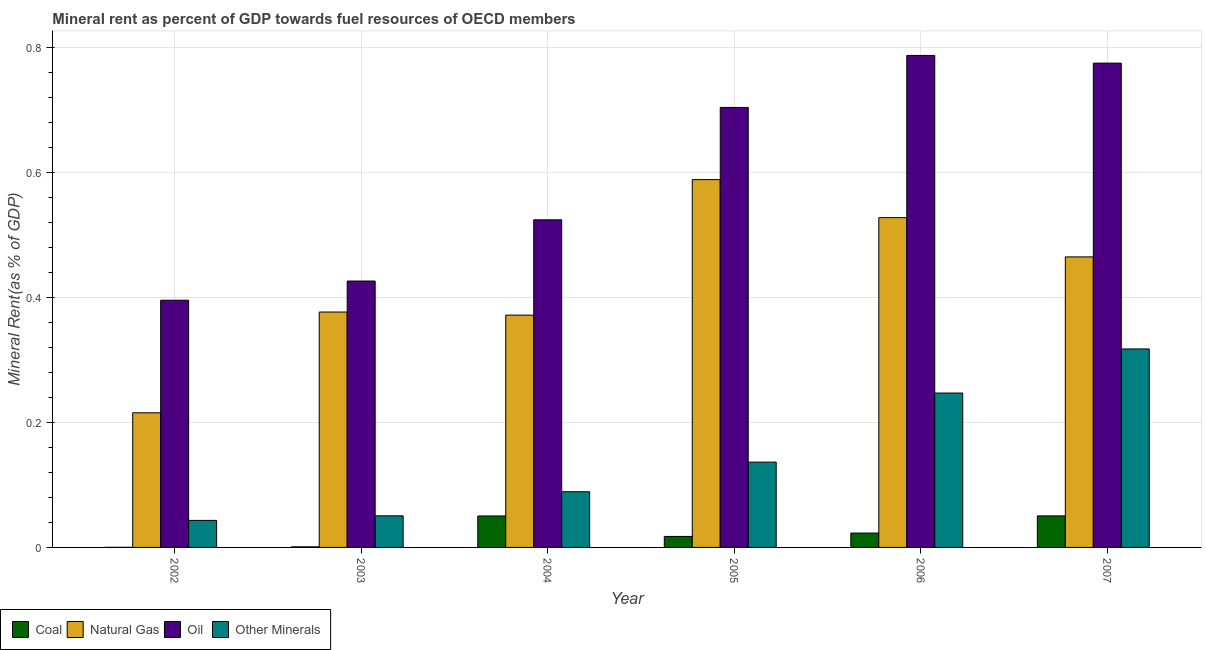How many different coloured bars are there?
Keep it short and to the point. 4. Are the number of bars per tick equal to the number of legend labels?
Offer a very short reply. Yes. Are the number of bars on each tick of the X-axis equal?
Offer a terse response. Yes. What is the label of the 1st group of bars from the left?
Your answer should be very brief. 2002. In how many cases, is the number of bars for a given year not equal to the number of legend labels?
Provide a succinct answer. 0. What is the natural gas rent in 2004?
Your response must be concise. 0.37. Across all years, what is the maximum natural gas rent?
Give a very brief answer. 0.59. Across all years, what is the minimum natural gas rent?
Your answer should be very brief. 0.22. What is the total coal rent in the graph?
Ensure brevity in your answer.  0.14. What is the difference between the coal rent in 2005 and that in 2006?
Provide a short and direct response. -0.01. What is the difference between the  rent of other minerals in 2004 and the coal rent in 2006?
Offer a very short reply. -0.16. What is the average  rent of other minerals per year?
Offer a very short reply. 0.15. In how many years, is the  rent of other minerals greater than 0.68 %?
Keep it short and to the point. 0. What is the ratio of the natural gas rent in 2004 to that in 2005?
Provide a succinct answer. 0.63. Is the difference between the coal rent in 2004 and 2006 greater than the difference between the oil rent in 2004 and 2006?
Offer a very short reply. No. What is the difference between the highest and the second highest natural gas rent?
Make the answer very short. 0.06. What is the difference between the highest and the lowest coal rent?
Ensure brevity in your answer.  0.05. Is it the case that in every year, the sum of the natural gas rent and coal rent is greater than the sum of oil rent and  rent of other minerals?
Your response must be concise. Yes. What does the 2nd bar from the left in 2006 represents?
Keep it short and to the point. Natural Gas. What does the 1st bar from the right in 2002 represents?
Your answer should be very brief. Other Minerals. Are all the bars in the graph horizontal?
Provide a succinct answer. No. How many years are there in the graph?
Keep it short and to the point. 6. What is the difference between two consecutive major ticks on the Y-axis?
Your answer should be very brief. 0.2. Are the values on the major ticks of Y-axis written in scientific E-notation?
Make the answer very short. No. Does the graph contain grids?
Your answer should be very brief. Yes. Where does the legend appear in the graph?
Keep it short and to the point. Bottom left. What is the title of the graph?
Your answer should be very brief. Mineral rent as percent of GDP towards fuel resources of OECD members. What is the label or title of the Y-axis?
Offer a very short reply. Mineral Rent(as % of GDP). What is the Mineral Rent(as % of GDP) in Coal in 2002?
Keep it short and to the point. 0. What is the Mineral Rent(as % of GDP) of Natural Gas in 2002?
Give a very brief answer. 0.22. What is the Mineral Rent(as % of GDP) in Oil in 2002?
Your answer should be compact. 0.4. What is the Mineral Rent(as % of GDP) in Other Minerals in 2002?
Your answer should be compact. 0.04. What is the Mineral Rent(as % of GDP) in Coal in 2003?
Offer a very short reply. 0. What is the Mineral Rent(as % of GDP) in Natural Gas in 2003?
Ensure brevity in your answer.  0.38. What is the Mineral Rent(as % of GDP) of Oil in 2003?
Your response must be concise. 0.43. What is the Mineral Rent(as % of GDP) of Other Minerals in 2003?
Offer a terse response. 0.05. What is the Mineral Rent(as % of GDP) in Coal in 2004?
Your answer should be very brief. 0.05. What is the Mineral Rent(as % of GDP) of Natural Gas in 2004?
Offer a terse response. 0.37. What is the Mineral Rent(as % of GDP) in Oil in 2004?
Provide a succinct answer. 0.52. What is the Mineral Rent(as % of GDP) in Other Minerals in 2004?
Your answer should be very brief. 0.09. What is the Mineral Rent(as % of GDP) of Coal in 2005?
Your answer should be compact. 0.02. What is the Mineral Rent(as % of GDP) in Natural Gas in 2005?
Offer a terse response. 0.59. What is the Mineral Rent(as % of GDP) in Oil in 2005?
Your answer should be compact. 0.7. What is the Mineral Rent(as % of GDP) of Other Minerals in 2005?
Your response must be concise. 0.14. What is the Mineral Rent(as % of GDP) in Coal in 2006?
Provide a short and direct response. 0.02. What is the Mineral Rent(as % of GDP) in Natural Gas in 2006?
Keep it short and to the point. 0.53. What is the Mineral Rent(as % of GDP) of Oil in 2006?
Provide a succinct answer. 0.79. What is the Mineral Rent(as % of GDP) of Other Minerals in 2006?
Your answer should be compact. 0.25. What is the Mineral Rent(as % of GDP) of Coal in 2007?
Keep it short and to the point. 0.05. What is the Mineral Rent(as % of GDP) of Natural Gas in 2007?
Offer a terse response. 0.46. What is the Mineral Rent(as % of GDP) of Oil in 2007?
Your answer should be very brief. 0.77. What is the Mineral Rent(as % of GDP) in Other Minerals in 2007?
Offer a terse response. 0.32. Across all years, what is the maximum Mineral Rent(as % of GDP) in Coal?
Ensure brevity in your answer.  0.05. Across all years, what is the maximum Mineral Rent(as % of GDP) in Natural Gas?
Keep it short and to the point. 0.59. Across all years, what is the maximum Mineral Rent(as % of GDP) in Oil?
Provide a succinct answer. 0.79. Across all years, what is the maximum Mineral Rent(as % of GDP) of Other Minerals?
Your answer should be very brief. 0.32. Across all years, what is the minimum Mineral Rent(as % of GDP) of Coal?
Ensure brevity in your answer.  0. Across all years, what is the minimum Mineral Rent(as % of GDP) of Natural Gas?
Give a very brief answer. 0.22. Across all years, what is the minimum Mineral Rent(as % of GDP) in Oil?
Your answer should be compact. 0.4. Across all years, what is the minimum Mineral Rent(as % of GDP) of Other Minerals?
Provide a succinct answer. 0.04. What is the total Mineral Rent(as % of GDP) of Coal in the graph?
Your answer should be compact. 0.14. What is the total Mineral Rent(as % of GDP) in Natural Gas in the graph?
Provide a short and direct response. 2.54. What is the total Mineral Rent(as % of GDP) of Oil in the graph?
Make the answer very short. 3.61. What is the total Mineral Rent(as % of GDP) in Other Minerals in the graph?
Provide a short and direct response. 0.88. What is the difference between the Mineral Rent(as % of GDP) of Coal in 2002 and that in 2003?
Give a very brief answer. -0. What is the difference between the Mineral Rent(as % of GDP) of Natural Gas in 2002 and that in 2003?
Give a very brief answer. -0.16. What is the difference between the Mineral Rent(as % of GDP) of Oil in 2002 and that in 2003?
Provide a short and direct response. -0.03. What is the difference between the Mineral Rent(as % of GDP) of Other Minerals in 2002 and that in 2003?
Your answer should be compact. -0.01. What is the difference between the Mineral Rent(as % of GDP) of Coal in 2002 and that in 2004?
Your answer should be very brief. -0.05. What is the difference between the Mineral Rent(as % of GDP) of Natural Gas in 2002 and that in 2004?
Ensure brevity in your answer.  -0.16. What is the difference between the Mineral Rent(as % of GDP) of Oil in 2002 and that in 2004?
Ensure brevity in your answer.  -0.13. What is the difference between the Mineral Rent(as % of GDP) of Other Minerals in 2002 and that in 2004?
Keep it short and to the point. -0.05. What is the difference between the Mineral Rent(as % of GDP) in Coal in 2002 and that in 2005?
Make the answer very short. -0.02. What is the difference between the Mineral Rent(as % of GDP) of Natural Gas in 2002 and that in 2005?
Provide a short and direct response. -0.37. What is the difference between the Mineral Rent(as % of GDP) of Oil in 2002 and that in 2005?
Your answer should be compact. -0.31. What is the difference between the Mineral Rent(as % of GDP) of Other Minerals in 2002 and that in 2005?
Your response must be concise. -0.09. What is the difference between the Mineral Rent(as % of GDP) of Coal in 2002 and that in 2006?
Your answer should be compact. -0.02. What is the difference between the Mineral Rent(as % of GDP) of Natural Gas in 2002 and that in 2006?
Give a very brief answer. -0.31. What is the difference between the Mineral Rent(as % of GDP) in Oil in 2002 and that in 2006?
Your answer should be compact. -0.39. What is the difference between the Mineral Rent(as % of GDP) in Other Minerals in 2002 and that in 2006?
Offer a very short reply. -0.2. What is the difference between the Mineral Rent(as % of GDP) of Coal in 2002 and that in 2007?
Offer a very short reply. -0.05. What is the difference between the Mineral Rent(as % of GDP) in Natural Gas in 2002 and that in 2007?
Keep it short and to the point. -0.25. What is the difference between the Mineral Rent(as % of GDP) in Oil in 2002 and that in 2007?
Your answer should be very brief. -0.38. What is the difference between the Mineral Rent(as % of GDP) of Other Minerals in 2002 and that in 2007?
Give a very brief answer. -0.27. What is the difference between the Mineral Rent(as % of GDP) in Coal in 2003 and that in 2004?
Ensure brevity in your answer.  -0.05. What is the difference between the Mineral Rent(as % of GDP) in Natural Gas in 2003 and that in 2004?
Provide a short and direct response. 0.01. What is the difference between the Mineral Rent(as % of GDP) in Oil in 2003 and that in 2004?
Offer a terse response. -0.1. What is the difference between the Mineral Rent(as % of GDP) of Other Minerals in 2003 and that in 2004?
Provide a succinct answer. -0.04. What is the difference between the Mineral Rent(as % of GDP) of Coal in 2003 and that in 2005?
Your answer should be very brief. -0.02. What is the difference between the Mineral Rent(as % of GDP) of Natural Gas in 2003 and that in 2005?
Your answer should be very brief. -0.21. What is the difference between the Mineral Rent(as % of GDP) of Oil in 2003 and that in 2005?
Your answer should be very brief. -0.28. What is the difference between the Mineral Rent(as % of GDP) of Other Minerals in 2003 and that in 2005?
Provide a short and direct response. -0.09. What is the difference between the Mineral Rent(as % of GDP) of Coal in 2003 and that in 2006?
Offer a terse response. -0.02. What is the difference between the Mineral Rent(as % of GDP) in Natural Gas in 2003 and that in 2006?
Make the answer very short. -0.15. What is the difference between the Mineral Rent(as % of GDP) of Oil in 2003 and that in 2006?
Your answer should be very brief. -0.36. What is the difference between the Mineral Rent(as % of GDP) of Other Minerals in 2003 and that in 2006?
Provide a short and direct response. -0.2. What is the difference between the Mineral Rent(as % of GDP) of Coal in 2003 and that in 2007?
Your response must be concise. -0.05. What is the difference between the Mineral Rent(as % of GDP) of Natural Gas in 2003 and that in 2007?
Your answer should be compact. -0.09. What is the difference between the Mineral Rent(as % of GDP) of Oil in 2003 and that in 2007?
Provide a succinct answer. -0.35. What is the difference between the Mineral Rent(as % of GDP) of Other Minerals in 2003 and that in 2007?
Offer a very short reply. -0.27. What is the difference between the Mineral Rent(as % of GDP) in Coal in 2004 and that in 2005?
Give a very brief answer. 0.03. What is the difference between the Mineral Rent(as % of GDP) in Natural Gas in 2004 and that in 2005?
Make the answer very short. -0.22. What is the difference between the Mineral Rent(as % of GDP) of Oil in 2004 and that in 2005?
Offer a very short reply. -0.18. What is the difference between the Mineral Rent(as % of GDP) of Other Minerals in 2004 and that in 2005?
Offer a terse response. -0.05. What is the difference between the Mineral Rent(as % of GDP) of Coal in 2004 and that in 2006?
Provide a succinct answer. 0.03. What is the difference between the Mineral Rent(as % of GDP) of Natural Gas in 2004 and that in 2006?
Provide a succinct answer. -0.16. What is the difference between the Mineral Rent(as % of GDP) of Oil in 2004 and that in 2006?
Offer a very short reply. -0.26. What is the difference between the Mineral Rent(as % of GDP) in Other Minerals in 2004 and that in 2006?
Offer a terse response. -0.16. What is the difference between the Mineral Rent(as % of GDP) of Coal in 2004 and that in 2007?
Your answer should be compact. -0. What is the difference between the Mineral Rent(as % of GDP) of Natural Gas in 2004 and that in 2007?
Your answer should be compact. -0.09. What is the difference between the Mineral Rent(as % of GDP) in Oil in 2004 and that in 2007?
Keep it short and to the point. -0.25. What is the difference between the Mineral Rent(as % of GDP) in Other Minerals in 2004 and that in 2007?
Ensure brevity in your answer.  -0.23. What is the difference between the Mineral Rent(as % of GDP) of Coal in 2005 and that in 2006?
Make the answer very short. -0.01. What is the difference between the Mineral Rent(as % of GDP) in Natural Gas in 2005 and that in 2006?
Make the answer very short. 0.06. What is the difference between the Mineral Rent(as % of GDP) of Oil in 2005 and that in 2006?
Your answer should be compact. -0.08. What is the difference between the Mineral Rent(as % of GDP) of Other Minerals in 2005 and that in 2006?
Give a very brief answer. -0.11. What is the difference between the Mineral Rent(as % of GDP) of Coal in 2005 and that in 2007?
Offer a very short reply. -0.03. What is the difference between the Mineral Rent(as % of GDP) in Natural Gas in 2005 and that in 2007?
Offer a very short reply. 0.12. What is the difference between the Mineral Rent(as % of GDP) in Oil in 2005 and that in 2007?
Provide a short and direct response. -0.07. What is the difference between the Mineral Rent(as % of GDP) in Other Minerals in 2005 and that in 2007?
Your response must be concise. -0.18. What is the difference between the Mineral Rent(as % of GDP) in Coal in 2006 and that in 2007?
Provide a short and direct response. -0.03. What is the difference between the Mineral Rent(as % of GDP) in Natural Gas in 2006 and that in 2007?
Provide a short and direct response. 0.06. What is the difference between the Mineral Rent(as % of GDP) in Oil in 2006 and that in 2007?
Your answer should be compact. 0.01. What is the difference between the Mineral Rent(as % of GDP) of Other Minerals in 2006 and that in 2007?
Your answer should be very brief. -0.07. What is the difference between the Mineral Rent(as % of GDP) of Coal in 2002 and the Mineral Rent(as % of GDP) of Natural Gas in 2003?
Ensure brevity in your answer.  -0.38. What is the difference between the Mineral Rent(as % of GDP) of Coal in 2002 and the Mineral Rent(as % of GDP) of Oil in 2003?
Your answer should be compact. -0.43. What is the difference between the Mineral Rent(as % of GDP) in Coal in 2002 and the Mineral Rent(as % of GDP) in Other Minerals in 2003?
Provide a succinct answer. -0.05. What is the difference between the Mineral Rent(as % of GDP) of Natural Gas in 2002 and the Mineral Rent(as % of GDP) of Oil in 2003?
Your answer should be compact. -0.21. What is the difference between the Mineral Rent(as % of GDP) of Natural Gas in 2002 and the Mineral Rent(as % of GDP) of Other Minerals in 2003?
Your answer should be very brief. 0.16. What is the difference between the Mineral Rent(as % of GDP) in Oil in 2002 and the Mineral Rent(as % of GDP) in Other Minerals in 2003?
Provide a succinct answer. 0.34. What is the difference between the Mineral Rent(as % of GDP) of Coal in 2002 and the Mineral Rent(as % of GDP) of Natural Gas in 2004?
Provide a succinct answer. -0.37. What is the difference between the Mineral Rent(as % of GDP) of Coal in 2002 and the Mineral Rent(as % of GDP) of Oil in 2004?
Give a very brief answer. -0.52. What is the difference between the Mineral Rent(as % of GDP) in Coal in 2002 and the Mineral Rent(as % of GDP) in Other Minerals in 2004?
Provide a succinct answer. -0.09. What is the difference between the Mineral Rent(as % of GDP) in Natural Gas in 2002 and the Mineral Rent(as % of GDP) in Oil in 2004?
Your response must be concise. -0.31. What is the difference between the Mineral Rent(as % of GDP) of Natural Gas in 2002 and the Mineral Rent(as % of GDP) of Other Minerals in 2004?
Keep it short and to the point. 0.13. What is the difference between the Mineral Rent(as % of GDP) of Oil in 2002 and the Mineral Rent(as % of GDP) of Other Minerals in 2004?
Provide a short and direct response. 0.31. What is the difference between the Mineral Rent(as % of GDP) in Coal in 2002 and the Mineral Rent(as % of GDP) in Natural Gas in 2005?
Provide a succinct answer. -0.59. What is the difference between the Mineral Rent(as % of GDP) in Coal in 2002 and the Mineral Rent(as % of GDP) in Oil in 2005?
Give a very brief answer. -0.7. What is the difference between the Mineral Rent(as % of GDP) of Coal in 2002 and the Mineral Rent(as % of GDP) of Other Minerals in 2005?
Your answer should be compact. -0.14. What is the difference between the Mineral Rent(as % of GDP) of Natural Gas in 2002 and the Mineral Rent(as % of GDP) of Oil in 2005?
Give a very brief answer. -0.49. What is the difference between the Mineral Rent(as % of GDP) in Natural Gas in 2002 and the Mineral Rent(as % of GDP) in Other Minerals in 2005?
Ensure brevity in your answer.  0.08. What is the difference between the Mineral Rent(as % of GDP) of Oil in 2002 and the Mineral Rent(as % of GDP) of Other Minerals in 2005?
Provide a succinct answer. 0.26. What is the difference between the Mineral Rent(as % of GDP) of Coal in 2002 and the Mineral Rent(as % of GDP) of Natural Gas in 2006?
Provide a succinct answer. -0.53. What is the difference between the Mineral Rent(as % of GDP) in Coal in 2002 and the Mineral Rent(as % of GDP) in Oil in 2006?
Give a very brief answer. -0.79. What is the difference between the Mineral Rent(as % of GDP) in Coal in 2002 and the Mineral Rent(as % of GDP) in Other Minerals in 2006?
Provide a short and direct response. -0.25. What is the difference between the Mineral Rent(as % of GDP) of Natural Gas in 2002 and the Mineral Rent(as % of GDP) of Oil in 2006?
Ensure brevity in your answer.  -0.57. What is the difference between the Mineral Rent(as % of GDP) in Natural Gas in 2002 and the Mineral Rent(as % of GDP) in Other Minerals in 2006?
Give a very brief answer. -0.03. What is the difference between the Mineral Rent(as % of GDP) of Oil in 2002 and the Mineral Rent(as % of GDP) of Other Minerals in 2006?
Provide a short and direct response. 0.15. What is the difference between the Mineral Rent(as % of GDP) in Coal in 2002 and the Mineral Rent(as % of GDP) in Natural Gas in 2007?
Provide a succinct answer. -0.46. What is the difference between the Mineral Rent(as % of GDP) in Coal in 2002 and the Mineral Rent(as % of GDP) in Oil in 2007?
Provide a short and direct response. -0.77. What is the difference between the Mineral Rent(as % of GDP) of Coal in 2002 and the Mineral Rent(as % of GDP) of Other Minerals in 2007?
Provide a short and direct response. -0.32. What is the difference between the Mineral Rent(as % of GDP) of Natural Gas in 2002 and the Mineral Rent(as % of GDP) of Oil in 2007?
Offer a terse response. -0.56. What is the difference between the Mineral Rent(as % of GDP) of Natural Gas in 2002 and the Mineral Rent(as % of GDP) of Other Minerals in 2007?
Ensure brevity in your answer.  -0.1. What is the difference between the Mineral Rent(as % of GDP) in Oil in 2002 and the Mineral Rent(as % of GDP) in Other Minerals in 2007?
Provide a short and direct response. 0.08. What is the difference between the Mineral Rent(as % of GDP) in Coal in 2003 and the Mineral Rent(as % of GDP) in Natural Gas in 2004?
Offer a very short reply. -0.37. What is the difference between the Mineral Rent(as % of GDP) in Coal in 2003 and the Mineral Rent(as % of GDP) in Oil in 2004?
Your answer should be compact. -0.52. What is the difference between the Mineral Rent(as % of GDP) of Coal in 2003 and the Mineral Rent(as % of GDP) of Other Minerals in 2004?
Your answer should be compact. -0.09. What is the difference between the Mineral Rent(as % of GDP) in Natural Gas in 2003 and the Mineral Rent(as % of GDP) in Oil in 2004?
Your response must be concise. -0.15. What is the difference between the Mineral Rent(as % of GDP) of Natural Gas in 2003 and the Mineral Rent(as % of GDP) of Other Minerals in 2004?
Provide a succinct answer. 0.29. What is the difference between the Mineral Rent(as % of GDP) of Oil in 2003 and the Mineral Rent(as % of GDP) of Other Minerals in 2004?
Keep it short and to the point. 0.34. What is the difference between the Mineral Rent(as % of GDP) of Coal in 2003 and the Mineral Rent(as % of GDP) of Natural Gas in 2005?
Your answer should be very brief. -0.59. What is the difference between the Mineral Rent(as % of GDP) of Coal in 2003 and the Mineral Rent(as % of GDP) of Oil in 2005?
Give a very brief answer. -0.7. What is the difference between the Mineral Rent(as % of GDP) of Coal in 2003 and the Mineral Rent(as % of GDP) of Other Minerals in 2005?
Keep it short and to the point. -0.14. What is the difference between the Mineral Rent(as % of GDP) in Natural Gas in 2003 and the Mineral Rent(as % of GDP) in Oil in 2005?
Your response must be concise. -0.33. What is the difference between the Mineral Rent(as % of GDP) in Natural Gas in 2003 and the Mineral Rent(as % of GDP) in Other Minerals in 2005?
Offer a terse response. 0.24. What is the difference between the Mineral Rent(as % of GDP) of Oil in 2003 and the Mineral Rent(as % of GDP) of Other Minerals in 2005?
Give a very brief answer. 0.29. What is the difference between the Mineral Rent(as % of GDP) in Coal in 2003 and the Mineral Rent(as % of GDP) in Natural Gas in 2006?
Your answer should be very brief. -0.53. What is the difference between the Mineral Rent(as % of GDP) of Coal in 2003 and the Mineral Rent(as % of GDP) of Oil in 2006?
Provide a short and direct response. -0.79. What is the difference between the Mineral Rent(as % of GDP) in Coal in 2003 and the Mineral Rent(as % of GDP) in Other Minerals in 2006?
Ensure brevity in your answer.  -0.25. What is the difference between the Mineral Rent(as % of GDP) of Natural Gas in 2003 and the Mineral Rent(as % of GDP) of Oil in 2006?
Keep it short and to the point. -0.41. What is the difference between the Mineral Rent(as % of GDP) in Natural Gas in 2003 and the Mineral Rent(as % of GDP) in Other Minerals in 2006?
Keep it short and to the point. 0.13. What is the difference between the Mineral Rent(as % of GDP) of Oil in 2003 and the Mineral Rent(as % of GDP) of Other Minerals in 2006?
Give a very brief answer. 0.18. What is the difference between the Mineral Rent(as % of GDP) of Coal in 2003 and the Mineral Rent(as % of GDP) of Natural Gas in 2007?
Offer a terse response. -0.46. What is the difference between the Mineral Rent(as % of GDP) of Coal in 2003 and the Mineral Rent(as % of GDP) of Oil in 2007?
Provide a succinct answer. -0.77. What is the difference between the Mineral Rent(as % of GDP) of Coal in 2003 and the Mineral Rent(as % of GDP) of Other Minerals in 2007?
Provide a succinct answer. -0.32. What is the difference between the Mineral Rent(as % of GDP) in Natural Gas in 2003 and the Mineral Rent(as % of GDP) in Oil in 2007?
Provide a short and direct response. -0.4. What is the difference between the Mineral Rent(as % of GDP) in Natural Gas in 2003 and the Mineral Rent(as % of GDP) in Other Minerals in 2007?
Offer a terse response. 0.06. What is the difference between the Mineral Rent(as % of GDP) in Oil in 2003 and the Mineral Rent(as % of GDP) in Other Minerals in 2007?
Your answer should be very brief. 0.11. What is the difference between the Mineral Rent(as % of GDP) of Coal in 2004 and the Mineral Rent(as % of GDP) of Natural Gas in 2005?
Your answer should be compact. -0.54. What is the difference between the Mineral Rent(as % of GDP) in Coal in 2004 and the Mineral Rent(as % of GDP) in Oil in 2005?
Your answer should be very brief. -0.65. What is the difference between the Mineral Rent(as % of GDP) of Coal in 2004 and the Mineral Rent(as % of GDP) of Other Minerals in 2005?
Your response must be concise. -0.09. What is the difference between the Mineral Rent(as % of GDP) in Natural Gas in 2004 and the Mineral Rent(as % of GDP) in Oil in 2005?
Provide a short and direct response. -0.33. What is the difference between the Mineral Rent(as % of GDP) in Natural Gas in 2004 and the Mineral Rent(as % of GDP) in Other Minerals in 2005?
Offer a very short reply. 0.24. What is the difference between the Mineral Rent(as % of GDP) in Oil in 2004 and the Mineral Rent(as % of GDP) in Other Minerals in 2005?
Your answer should be very brief. 0.39. What is the difference between the Mineral Rent(as % of GDP) of Coal in 2004 and the Mineral Rent(as % of GDP) of Natural Gas in 2006?
Give a very brief answer. -0.48. What is the difference between the Mineral Rent(as % of GDP) of Coal in 2004 and the Mineral Rent(as % of GDP) of Oil in 2006?
Make the answer very short. -0.74. What is the difference between the Mineral Rent(as % of GDP) of Coal in 2004 and the Mineral Rent(as % of GDP) of Other Minerals in 2006?
Ensure brevity in your answer.  -0.2. What is the difference between the Mineral Rent(as % of GDP) in Natural Gas in 2004 and the Mineral Rent(as % of GDP) in Oil in 2006?
Provide a succinct answer. -0.42. What is the difference between the Mineral Rent(as % of GDP) of Natural Gas in 2004 and the Mineral Rent(as % of GDP) of Other Minerals in 2006?
Provide a short and direct response. 0.12. What is the difference between the Mineral Rent(as % of GDP) in Oil in 2004 and the Mineral Rent(as % of GDP) in Other Minerals in 2006?
Provide a short and direct response. 0.28. What is the difference between the Mineral Rent(as % of GDP) of Coal in 2004 and the Mineral Rent(as % of GDP) of Natural Gas in 2007?
Offer a very short reply. -0.41. What is the difference between the Mineral Rent(as % of GDP) of Coal in 2004 and the Mineral Rent(as % of GDP) of Oil in 2007?
Give a very brief answer. -0.72. What is the difference between the Mineral Rent(as % of GDP) in Coal in 2004 and the Mineral Rent(as % of GDP) in Other Minerals in 2007?
Ensure brevity in your answer.  -0.27. What is the difference between the Mineral Rent(as % of GDP) in Natural Gas in 2004 and the Mineral Rent(as % of GDP) in Oil in 2007?
Provide a succinct answer. -0.4. What is the difference between the Mineral Rent(as % of GDP) of Natural Gas in 2004 and the Mineral Rent(as % of GDP) of Other Minerals in 2007?
Offer a very short reply. 0.05. What is the difference between the Mineral Rent(as % of GDP) in Oil in 2004 and the Mineral Rent(as % of GDP) in Other Minerals in 2007?
Ensure brevity in your answer.  0.21. What is the difference between the Mineral Rent(as % of GDP) in Coal in 2005 and the Mineral Rent(as % of GDP) in Natural Gas in 2006?
Keep it short and to the point. -0.51. What is the difference between the Mineral Rent(as % of GDP) of Coal in 2005 and the Mineral Rent(as % of GDP) of Oil in 2006?
Provide a short and direct response. -0.77. What is the difference between the Mineral Rent(as % of GDP) in Coal in 2005 and the Mineral Rent(as % of GDP) in Other Minerals in 2006?
Your response must be concise. -0.23. What is the difference between the Mineral Rent(as % of GDP) in Natural Gas in 2005 and the Mineral Rent(as % of GDP) in Oil in 2006?
Provide a succinct answer. -0.2. What is the difference between the Mineral Rent(as % of GDP) in Natural Gas in 2005 and the Mineral Rent(as % of GDP) in Other Minerals in 2006?
Give a very brief answer. 0.34. What is the difference between the Mineral Rent(as % of GDP) in Oil in 2005 and the Mineral Rent(as % of GDP) in Other Minerals in 2006?
Your response must be concise. 0.46. What is the difference between the Mineral Rent(as % of GDP) in Coal in 2005 and the Mineral Rent(as % of GDP) in Natural Gas in 2007?
Provide a succinct answer. -0.45. What is the difference between the Mineral Rent(as % of GDP) in Coal in 2005 and the Mineral Rent(as % of GDP) in Oil in 2007?
Your response must be concise. -0.76. What is the difference between the Mineral Rent(as % of GDP) in Coal in 2005 and the Mineral Rent(as % of GDP) in Other Minerals in 2007?
Ensure brevity in your answer.  -0.3. What is the difference between the Mineral Rent(as % of GDP) in Natural Gas in 2005 and the Mineral Rent(as % of GDP) in Oil in 2007?
Your response must be concise. -0.19. What is the difference between the Mineral Rent(as % of GDP) in Natural Gas in 2005 and the Mineral Rent(as % of GDP) in Other Minerals in 2007?
Your answer should be compact. 0.27. What is the difference between the Mineral Rent(as % of GDP) of Oil in 2005 and the Mineral Rent(as % of GDP) of Other Minerals in 2007?
Provide a succinct answer. 0.39. What is the difference between the Mineral Rent(as % of GDP) of Coal in 2006 and the Mineral Rent(as % of GDP) of Natural Gas in 2007?
Offer a terse response. -0.44. What is the difference between the Mineral Rent(as % of GDP) in Coal in 2006 and the Mineral Rent(as % of GDP) in Oil in 2007?
Your answer should be compact. -0.75. What is the difference between the Mineral Rent(as % of GDP) of Coal in 2006 and the Mineral Rent(as % of GDP) of Other Minerals in 2007?
Offer a very short reply. -0.29. What is the difference between the Mineral Rent(as % of GDP) of Natural Gas in 2006 and the Mineral Rent(as % of GDP) of Oil in 2007?
Make the answer very short. -0.25. What is the difference between the Mineral Rent(as % of GDP) in Natural Gas in 2006 and the Mineral Rent(as % of GDP) in Other Minerals in 2007?
Keep it short and to the point. 0.21. What is the difference between the Mineral Rent(as % of GDP) of Oil in 2006 and the Mineral Rent(as % of GDP) of Other Minerals in 2007?
Your answer should be very brief. 0.47. What is the average Mineral Rent(as % of GDP) of Coal per year?
Provide a short and direct response. 0.02. What is the average Mineral Rent(as % of GDP) in Natural Gas per year?
Keep it short and to the point. 0.42. What is the average Mineral Rent(as % of GDP) in Oil per year?
Your answer should be compact. 0.6. What is the average Mineral Rent(as % of GDP) of Other Minerals per year?
Your response must be concise. 0.15. In the year 2002, what is the difference between the Mineral Rent(as % of GDP) in Coal and Mineral Rent(as % of GDP) in Natural Gas?
Your answer should be very brief. -0.22. In the year 2002, what is the difference between the Mineral Rent(as % of GDP) of Coal and Mineral Rent(as % of GDP) of Oil?
Provide a short and direct response. -0.4. In the year 2002, what is the difference between the Mineral Rent(as % of GDP) in Coal and Mineral Rent(as % of GDP) in Other Minerals?
Provide a short and direct response. -0.04. In the year 2002, what is the difference between the Mineral Rent(as % of GDP) in Natural Gas and Mineral Rent(as % of GDP) in Oil?
Ensure brevity in your answer.  -0.18. In the year 2002, what is the difference between the Mineral Rent(as % of GDP) in Natural Gas and Mineral Rent(as % of GDP) in Other Minerals?
Offer a very short reply. 0.17. In the year 2002, what is the difference between the Mineral Rent(as % of GDP) in Oil and Mineral Rent(as % of GDP) in Other Minerals?
Ensure brevity in your answer.  0.35. In the year 2003, what is the difference between the Mineral Rent(as % of GDP) of Coal and Mineral Rent(as % of GDP) of Natural Gas?
Ensure brevity in your answer.  -0.38. In the year 2003, what is the difference between the Mineral Rent(as % of GDP) in Coal and Mineral Rent(as % of GDP) in Oil?
Make the answer very short. -0.43. In the year 2003, what is the difference between the Mineral Rent(as % of GDP) of Coal and Mineral Rent(as % of GDP) of Other Minerals?
Provide a short and direct response. -0.05. In the year 2003, what is the difference between the Mineral Rent(as % of GDP) of Natural Gas and Mineral Rent(as % of GDP) of Oil?
Provide a succinct answer. -0.05. In the year 2003, what is the difference between the Mineral Rent(as % of GDP) of Natural Gas and Mineral Rent(as % of GDP) of Other Minerals?
Offer a very short reply. 0.33. In the year 2003, what is the difference between the Mineral Rent(as % of GDP) in Oil and Mineral Rent(as % of GDP) in Other Minerals?
Offer a terse response. 0.38. In the year 2004, what is the difference between the Mineral Rent(as % of GDP) of Coal and Mineral Rent(as % of GDP) of Natural Gas?
Provide a succinct answer. -0.32. In the year 2004, what is the difference between the Mineral Rent(as % of GDP) in Coal and Mineral Rent(as % of GDP) in Oil?
Provide a succinct answer. -0.47. In the year 2004, what is the difference between the Mineral Rent(as % of GDP) in Coal and Mineral Rent(as % of GDP) in Other Minerals?
Give a very brief answer. -0.04. In the year 2004, what is the difference between the Mineral Rent(as % of GDP) in Natural Gas and Mineral Rent(as % of GDP) in Oil?
Your response must be concise. -0.15. In the year 2004, what is the difference between the Mineral Rent(as % of GDP) of Natural Gas and Mineral Rent(as % of GDP) of Other Minerals?
Give a very brief answer. 0.28. In the year 2004, what is the difference between the Mineral Rent(as % of GDP) of Oil and Mineral Rent(as % of GDP) of Other Minerals?
Ensure brevity in your answer.  0.43. In the year 2005, what is the difference between the Mineral Rent(as % of GDP) of Coal and Mineral Rent(as % of GDP) of Natural Gas?
Give a very brief answer. -0.57. In the year 2005, what is the difference between the Mineral Rent(as % of GDP) in Coal and Mineral Rent(as % of GDP) in Oil?
Provide a succinct answer. -0.69. In the year 2005, what is the difference between the Mineral Rent(as % of GDP) in Coal and Mineral Rent(as % of GDP) in Other Minerals?
Make the answer very short. -0.12. In the year 2005, what is the difference between the Mineral Rent(as % of GDP) in Natural Gas and Mineral Rent(as % of GDP) in Oil?
Give a very brief answer. -0.12. In the year 2005, what is the difference between the Mineral Rent(as % of GDP) of Natural Gas and Mineral Rent(as % of GDP) of Other Minerals?
Ensure brevity in your answer.  0.45. In the year 2005, what is the difference between the Mineral Rent(as % of GDP) in Oil and Mineral Rent(as % of GDP) in Other Minerals?
Give a very brief answer. 0.57. In the year 2006, what is the difference between the Mineral Rent(as % of GDP) of Coal and Mineral Rent(as % of GDP) of Natural Gas?
Your answer should be compact. -0.5. In the year 2006, what is the difference between the Mineral Rent(as % of GDP) in Coal and Mineral Rent(as % of GDP) in Oil?
Offer a terse response. -0.76. In the year 2006, what is the difference between the Mineral Rent(as % of GDP) in Coal and Mineral Rent(as % of GDP) in Other Minerals?
Your answer should be compact. -0.22. In the year 2006, what is the difference between the Mineral Rent(as % of GDP) in Natural Gas and Mineral Rent(as % of GDP) in Oil?
Offer a very short reply. -0.26. In the year 2006, what is the difference between the Mineral Rent(as % of GDP) in Natural Gas and Mineral Rent(as % of GDP) in Other Minerals?
Offer a very short reply. 0.28. In the year 2006, what is the difference between the Mineral Rent(as % of GDP) in Oil and Mineral Rent(as % of GDP) in Other Minerals?
Provide a short and direct response. 0.54. In the year 2007, what is the difference between the Mineral Rent(as % of GDP) of Coal and Mineral Rent(as % of GDP) of Natural Gas?
Keep it short and to the point. -0.41. In the year 2007, what is the difference between the Mineral Rent(as % of GDP) of Coal and Mineral Rent(as % of GDP) of Oil?
Ensure brevity in your answer.  -0.72. In the year 2007, what is the difference between the Mineral Rent(as % of GDP) in Coal and Mineral Rent(as % of GDP) in Other Minerals?
Make the answer very short. -0.27. In the year 2007, what is the difference between the Mineral Rent(as % of GDP) in Natural Gas and Mineral Rent(as % of GDP) in Oil?
Offer a very short reply. -0.31. In the year 2007, what is the difference between the Mineral Rent(as % of GDP) in Natural Gas and Mineral Rent(as % of GDP) in Other Minerals?
Provide a succinct answer. 0.15. In the year 2007, what is the difference between the Mineral Rent(as % of GDP) of Oil and Mineral Rent(as % of GDP) of Other Minerals?
Offer a very short reply. 0.46. What is the ratio of the Mineral Rent(as % of GDP) of Coal in 2002 to that in 2003?
Keep it short and to the point. 0.16. What is the ratio of the Mineral Rent(as % of GDP) of Natural Gas in 2002 to that in 2003?
Your answer should be compact. 0.57. What is the ratio of the Mineral Rent(as % of GDP) in Oil in 2002 to that in 2003?
Your answer should be compact. 0.93. What is the ratio of the Mineral Rent(as % of GDP) of Other Minerals in 2002 to that in 2003?
Make the answer very short. 0.86. What is the ratio of the Mineral Rent(as % of GDP) in Coal in 2002 to that in 2004?
Make the answer very short. 0. What is the ratio of the Mineral Rent(as % of GDP) in Natural Gas in 2002 to that in 2004?
Ensure brevity in your answer.  0.58. What is the ratio of the Mineral Rent(as % of GDP) of Oil in 2002 to that in 2004?
Give a very brief answer. 0.75. What is the ratio of the Mineral Rent(as % of GDP) in Other Minerals in 2002 to that in 2004?
Your response must be concise. 0.49. What is the ratio of the Mineral Rent(as % of GDP) of Coal in 2002 to that in 2005?
Provide a short and direct response. 0.01. What is the ratio of the Mineral Rent(as % of GDP) in Natural Gas in 2002 to that in 2005?
Ensure brevity in your answer.  0.37. What is the ratio of the Mineral Rent(as % of GDP) in Oil in 2002 to that in 2005?
Give a very brief answer. 0.56. What is the ratio of the Mineral Rent(as % of GDP) in Other Minerals in 2002 to that in 2005?
Your answer should be very brief. 0.32. What is the ratio of the Mineral Rent(as % of GDP) in Coal in 2002 to that in 2006?
Ensure brevity in your answer.  0.01. What is the ratio of the Mineral Rent(as % of GDP) in Natural Gas in 2002 to that in 2006?
Give a very brief answer. 0.41. What is the ratio of the Mineral Rent(as % of GDP) of Oil in 2002 to that in 2006?
Make the answer very short. 0.5. What is the ratio of the Mineral Rent(as % of GDP) of Other Minerals in 2002 to that in 2006?
Offer a very short reply. 0.18. What is the ratio of the Mineral Rent(as % of GDP) of Coal in 2002 to that in 2007?
Ensure brevity in your answer.  0. What is the ratio of the Mineral Rent(as % of GDP) in Natural Gas in 2002 to that in 2007?
Your response must be concise. 0.46. What is the ratio of the Mineral Rent(as % of GDP) in Oil in 2002 to that in 2007?
Ensure brevity in your answer.  0.51. What is the ratio of the Mineral Rent(as % of GDP) of Other Minerals in 2002 to that in 2007?
Offer a terse response. 0.14. What is the ratio of the Mineral Rent(as % of GDP) of Coal in 2003 to that in 2004?
Your response must be concise. 0.02. What is the ratio of the Mineral Rent(as % of GDP) of Natural Gas in 2003 to that in 2004?
Give a very brief answer. 1.01. What is the ratio of the Mineral Rent(as % of GDP) of Oil in 2003 to that in 2004?
Your response must be concise. 0.81. What is the ratio of the Mineral Rent(as % of GDP) of Other Minerals in 2003 to that in 2004?
Ensure brevity in your answer.  0.57. What is the ratio of the Mineral Rent(as % of GDP) of Coal in 2003 to that in 2005?
Make the answer very short. 0.05. What is the ratio of the Mineral Rent(as % of GDP) in Natural Gas in 2003 to that in 2005?
Provide a short and direct response. 0.64. What is the ratio of the Mineral Rent(as % of GDP) of Oil in 2003 to that in 2005?
Make the answer very short. 0.61. What is the ratio of the Mineral Rent(as % of GDP) of Other Minerals in 2003 to that in 2005?
Provide a succinct answer. 0.37. What is the ratio of the Mineral Rent(as % of GDP) in Coal in 2003 to that in 2006?
Your answer should be compact. 0.04. What is the ratio of the Mineral Rent(as % of GDP) of Natural Gas in 2003 to that in 2006?
Your response must be concise. 0.71. What is the ratio of the Mineral Rent(as % of GDP) of Oil in 2003 to that in 2006?
Make the answer very short. 0.54. What is the ratio of the Mineral Rent(as % of GDP) in Other Minerals in 2003 to that in 2006?
Make the answer very short. 0.2. What is the ratio of the Mineral Rent(as % of GDP) of Coal in 2003 to that in 2007?
Ensure brevity in your answer.  0.02. What is the ratio of the Mineral Rent(as % of GDP) in Natural Gas in 2003 to that in 2007?
Make the answer very short. 0.81. What is the ratio of the Mineral Rent(as % of GDP) of Oil in 2003 to that in 2007?
Keep it short and to the point. 0.55. What is the ratio of the Mineral Rent(as % of GDP) in Other Minerals in 2003 to that in 2007?
Offer a terse response. 0.16. What is the ratio of the Mineral Rent(as % of GDP) in Coal in 2004 to that in 2005?
Make the answer very short. 2.86. What is the ratio of the Mineral Rent(as % of GDP) in Natural Gas in 2004 to that in 2005?
Keep it short and to the point. 0.63. What is the ratio of the Mineral Rent(as % of GDP) of Oil in 2004 to that in 2005?
Make the answer very short. 0.74. What is the ratio of the Mineral Rent(as % of GDP) in Other Minerals in 2004 to that in 2005?
Offer a very short reply. 0.65. What is the ratio of the Mineral Rent(as % of GDP) in Coal in 2004 to that in 2006?
Keep it short and to the point. 2.19. What is the ratio of the Mineral Rent(as % of GDP) of Natural Gas in 2004 to that in 2006?
Offer a terse response. 0.7. What is the ratio of the Mineral Rent(as % of GDP) in Oil in 2004 to that in 2006?
Your answer should be very brief. 0.67. What is the ratio of the Mineral Rent(as % of GDP) of Other Minerals in 2004 to that in 2006?
Offer a very short reply. 0.36. What is the ratio of the Mineral Rent(as % of GDP) of Coal in 2004 to that in 2007?
Your answer should be compact. 1. What is the ratio of the Mineral Rent(as % of GDP) in Natural Gas in 2004 to that in 2007?
Your answer should be compact. 0.8. What is the ratio of the Mineral Rent(as % of GDP) in Oil in 2004 to that in 2007?
Keep it short and to the point. 0.68. What is the ratio of the Mineral Rent(as % of GDP) of Other Minerals in 2004 to that in 2007?
Offer a terse response. 0.28. What is the ratio of the Mineral Rent(as % of GDP) in Coal in 2005 to that in 2006?
Make the answer very short. 0.77. What is the ratio of the Mineral Rent(as % of GDP) in Natural Gas in 2005 to that in 2006?
Offer a very short reply. 1.12. What is the ratio of the Mineral Rent(as % of GDP) in Oil in 2005 to that in 2006?
Your answer should be very brief. 0.89. What is the ratio of the Mineral Rent(as % of GDP) in Other Minerals in 2005 to that in 2006?
Ensure brevity in your answer.  0.55. What is the ratio of the Mineral Rent(as % of GDP) of Coal in 2005 to that in 2007?
Offer a terse response. 0.35. What is the ratio of the Mineral Rent(as % of GDP) of Natural Gas in 2005 to that in 2007?
Provide a short and direct response. 1.27. What is the ratio of the Mineral Rent(as % of GDP) of Oil in 2005 to that in 2007?
Offer a terse response. 0.91. What is the ratio of the Mineral Rent(as % of GDP) of Other Minerals in 2005 to that in 2007?
Offer a very short reply. 0.43. What is the ratio of the Mineral Rent(as % of GDP) in Coal in 2006 to that in 2007?
Provide a short and direct response. 0.46. What is the ratio of the Mineral Rent(as % of GDP) of Natural Gas in 2006 to that in 2007?
Offer a terse response. 1.14. What is the ratio of the Mineral Rent(as % of GDP) in Oil in 2006 to that in 2007?
Make the answer very short. 1.02. What is the difference between the highest and the second highest Mineral Rent(as % of GDP) in Coal?
Your response must be concise. 0. What is the difference between the highest and the second highest Mineral Rent(as % of GDP) in Natural Gas?
Give a very brief answer. 0.06. What is the difference between the highest and the second highest Mineral Rent(as % of GDP) of Oil?
Your response must be concise. 0.01. What is the difference between the highest and the second highest Mineral Rent(as % of GDP) in Other Minerals?
Offer a terse response. 0.07. What is the difference between the highest and the lowest Mineral Rent(as % of GDP) of Coal?
Keep it short and to the point. 0.05. What is the difference between the highest and the lowest Mineral Rent(as % of GDP) in Natural Gas?
Provide a short and direct response. 0.37. What is the difference between the highest and the lowest Mineral Rent(as % of GDP) in Oil?
Provide a succinct answer. 0.39. What is the difference between the highest and the lowest Mineral Rent(as % of GDP) in Other Minerals?
Ensure brevity in your answer.  0.27. 